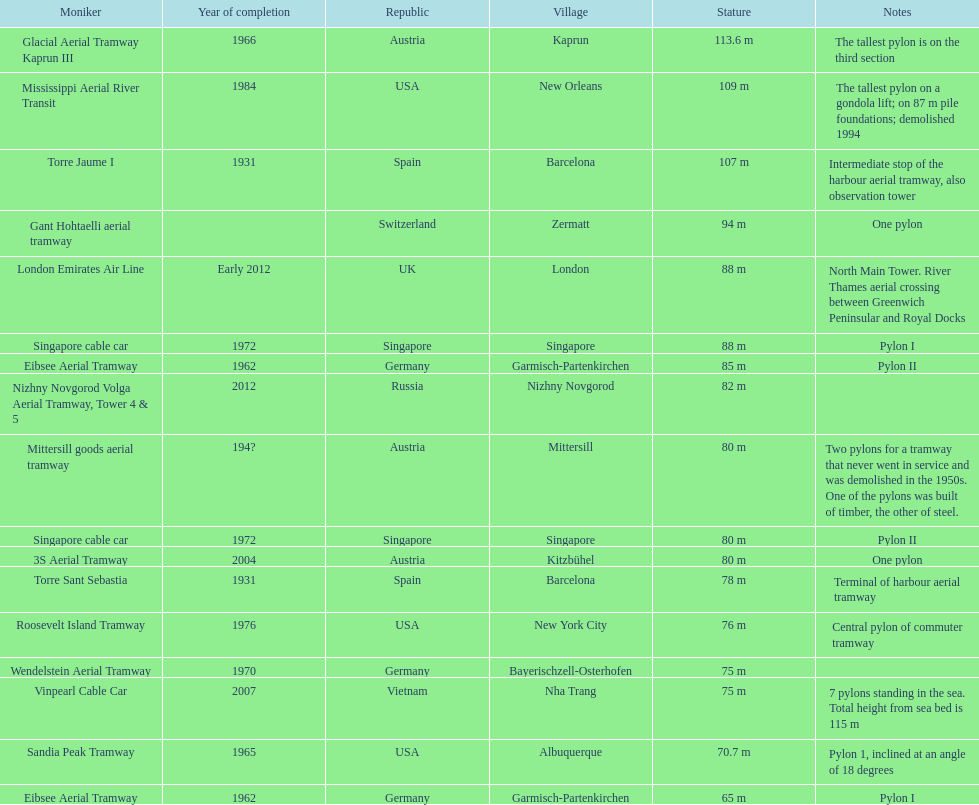How many pylons are in austria? 3. 